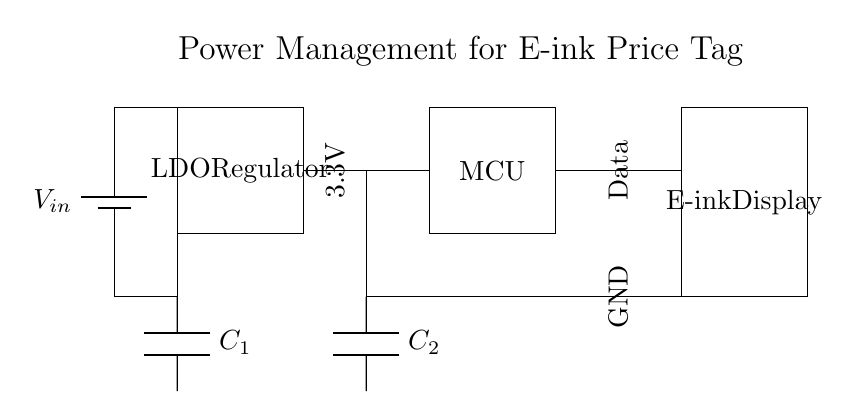What is the input voltage for this circuit? The input voltage is represented as V_in, which is connected directly to the LDO Regulator in the circuit. This is the voltage that the power management system receives.
Answer: V_in What component regulates the voltage in this circuit? The component responsible for regulating the voltage is the LDO Regulator. It takes the input voltage and provides a stable output voltage to the microcontroller and e-ink display.
Answer: LDO Regulator What is the output voltage of the LDO Regulator? The output voltage of the LDO Regulator is marked as 3.3V in the circuit diagram. This indicates the voltage level that the components downstream will receive.
Answer: 3.3V How many capacitors are present in the circuit? There are two capacitors shown in the circuit diagram, labeled as C1 and C2. Each capacitor plays a role in filtering or stabilizing the power supply.
Answer: 2 What is the primary function of the microcontroller in this circuit? The primary function of the microcontroller (MCU) is to control the e-ink display, managing data communication and display updates based on input from the power management circuit.
Answer: Control What are the connections from the LDO Regulator to the e-ink display? The LDO Regulator connects to the microcontroller first, which then connects to the e-ink display. The output voltage from the LDO goes to the microcontroller that communicates with the e-ink display.
Answer: LDO to MCU to E-ink Display What is the role of capacitors C1 and C2 in this circuit? Capacitor C1 is connected to the LDO Regulator and is used for input stabilization, while capacitor C2 is used for output stabilization at the MCU. They help ensure that the voltage remains stable during operation.
Answer: Stabilization 